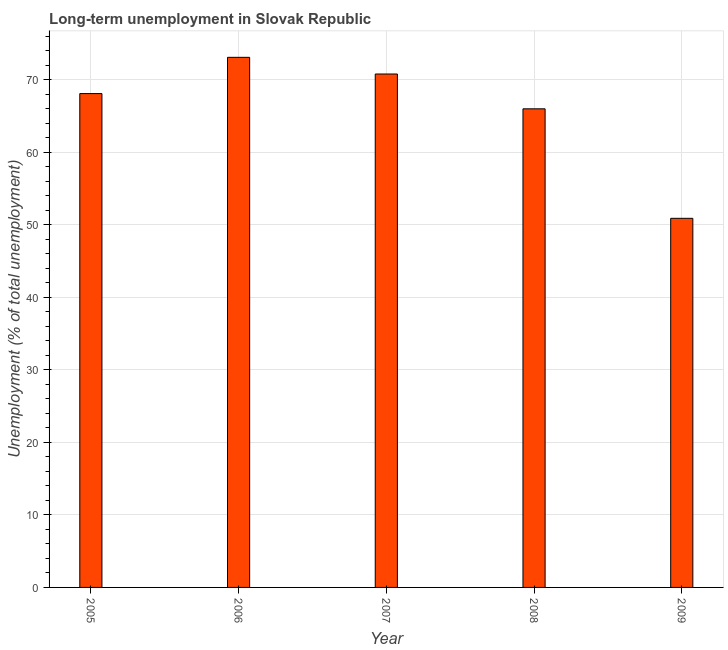Does the graph contain any zero values?
Keep it short and to the point. No. What is the title of the graph?
Offer a very short reply. Long-term unemployment in Slovak Republic. What is the label or title of the X-axis?
Offer a terse response. Year. What is the label or title of the Y-axis?
Your answer should be compact. Unemployment (% of total unemployment). What is the long-term unemployment in 2006?
Make the answer very short. 73.1. Across all years, what is the maximum long-term unemployment?
Your response must be concise. 73.1. Across all years, what is the minimum long-term unemployment?
Your response must be concise. 50.9. What is the sum of the long-term unemployment?
Ensure brevity in your answer.  328.9. What is the difference between the long-term unemployment in 2005 and 2006?
Offer a very short reply. -5. What is the average long-term unemployment per year?
Offer a terse response. 65.78. What is the median long-term unemployment?
Offer a very short reply. 68.1. What is the ratio of the long-term unemployment in 2005 to that in 2008?
Provide a short and direct response. 1.03. Is the long-term unemployment in 2005 less than that in 2008?
Provide a succinct answer. No. What is the difference between the highest and the second highest long-term unemployment?
Keep it short and to the point. 2.3. Are all the bars in the graph horizontal?
Ensure brevity in your answer.  No. How many years are there in the graph?
Your answer should be very brief. 5. Are the values on the major ticks of Y-axis written in scientific E-notation?
Your response must be concise. No. What is the Unemployment (% of total unemployment) in 2005?
Your response must be concise. 68.1. What is the Unemployment (% of total unemployment) in 2006?
Make the answer very short. 73.1. What is the Unemployment (% of total unemployment) of 2007?
Ensure brevity in your answer.  70.8. What is the Unemployment (% of total unemployment) of 2008?
Your answer should be compact. 66. What is the Unemployment (% of total unemployment) in 2009?
Provide a short and direct response. 50.9. What is the difference between the Unemployment (% of total unemployment) in 2005 and 2006?
Keep it short and to the point. -5. What is the difference between the Unemployment (% of total unemployment) in 2005 and 2008?
Ensure brevity in your answer.  2.1. What is the difference between the Unemployment (% of total unemployment) in 2005 and 2009?
Your answer should be very brief. 17.2. What is the difference between the Unemployment (% of total unemployment) in 2006 and 2007?
Give a very brief answer. 2.3. What is the difference between the Unemployment (% of total unemployment) in 2006 and 2008?
Offer a very short reply. 7.1. What is the difference between the Unemployment (% of total unemployment) in 2008 and 2009?
Offer a terse response. 15.1. What is the ratio of the Unemployment (% of total unemployment) in 2005 to that in 2006?
Keep it short and to the point. 0.93. What is the ratio of the Unemployment (% of total unemployment) in 2005 to that in 2008?
Your answer should be compact. 1.03. What is the ratio of the Unemployment (% of total unemployment) in 2005 to that in 2009?
Make the answer very short. 1.34. What is the ratio of the Unemployment (% of total unemployment) in 2006 to that in 2007?
Provide a short and direct response. 1.03. What is the ratio of the Unemployment (% of total unemployment) in 2006 to that in 2008?
Keep it short and to the point. 1.11. What is the ratio of the Unemployment (% of total unemployment) in 2006 to that in 2009?
Provide a succinct answer. 1.44. What is the ratio of the Unemployment (% of total unemployment) in 2007 to that in 2008?
Provide a short and direct response. 1.07. What is the ratio of the Unemployment (% of total unemployment) in 2007 to that in 2009?
Provide a short and direct response. 1.39. What is the ratio of the Unemployment (% of total unemployment) in 2008 to that in 2009?
Make the answer very short. 1.3. 